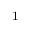Convert formula to latex. <formula><loc_0><loc_0><loc_500><loc_500>^ { 1</formula> 